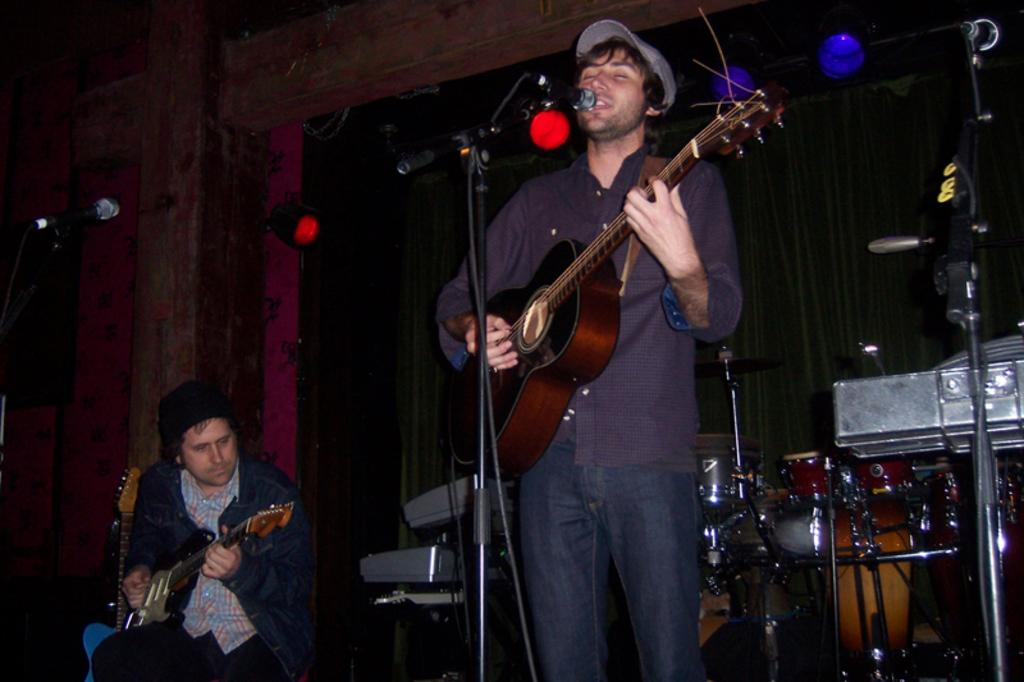How many people are in the image? There are two persons in the image. What is one person doing in the image? One person is sitting and playing a guitar. What is the other person doing in the image? The other person is standing in front of a microphone and also playing a guitar. Can you see any mice in the image? No, there are no mice present in the image. What type of ocean is visible in the background of the image? There is no ocean visible in the image; it features two people playing guitars and standing near a microphone. 